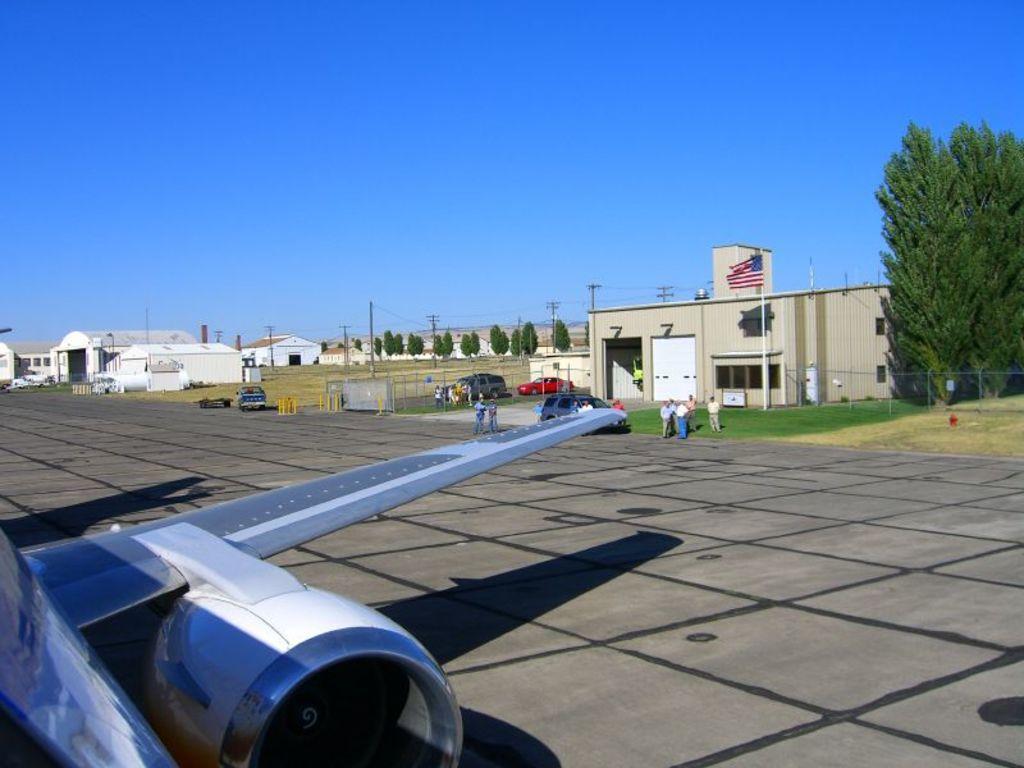Describe this image in one or two sentences. In the bottom left corner of the image we can see a plane. In the middle of the image we can see some vehicles, poles, trees, buildings and few people are standing. At the top of the image we can see the sky. 